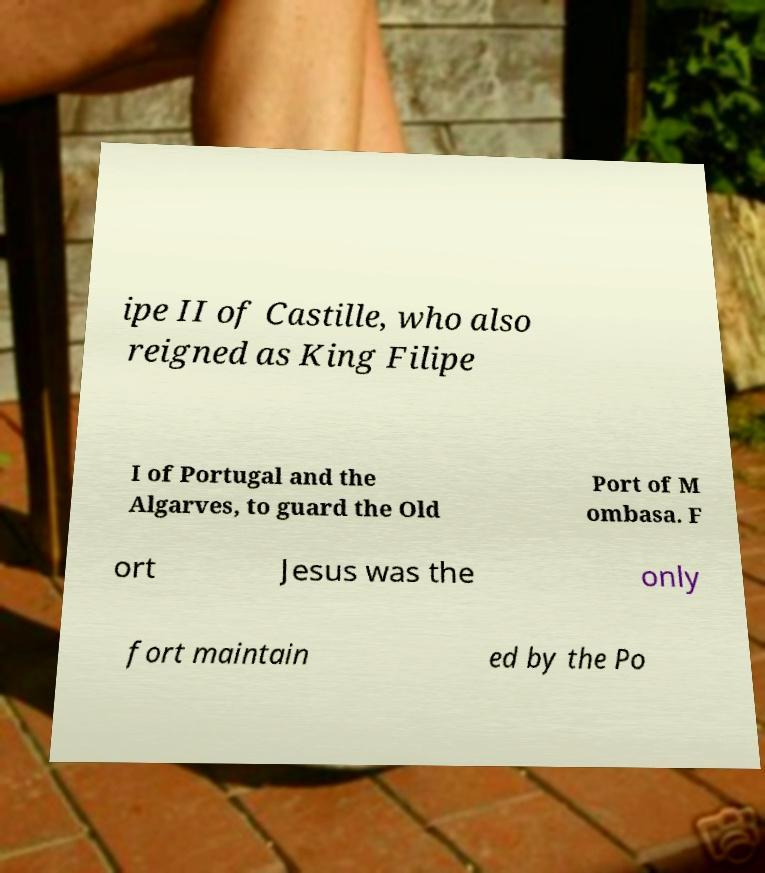Can you accurately transcribe the text from the provided image for me? ipe II of Castille, who also reigned as King Filipe I of Portugal and the Algarves, to guard the Old Port of M ombasa. F ort Jesus was the only fort maintain ed by the Po 